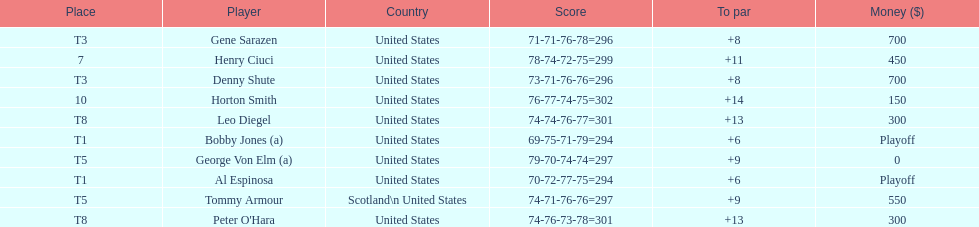Which two players tied for first place? Bobby Jones (a), Al Espinosa. 